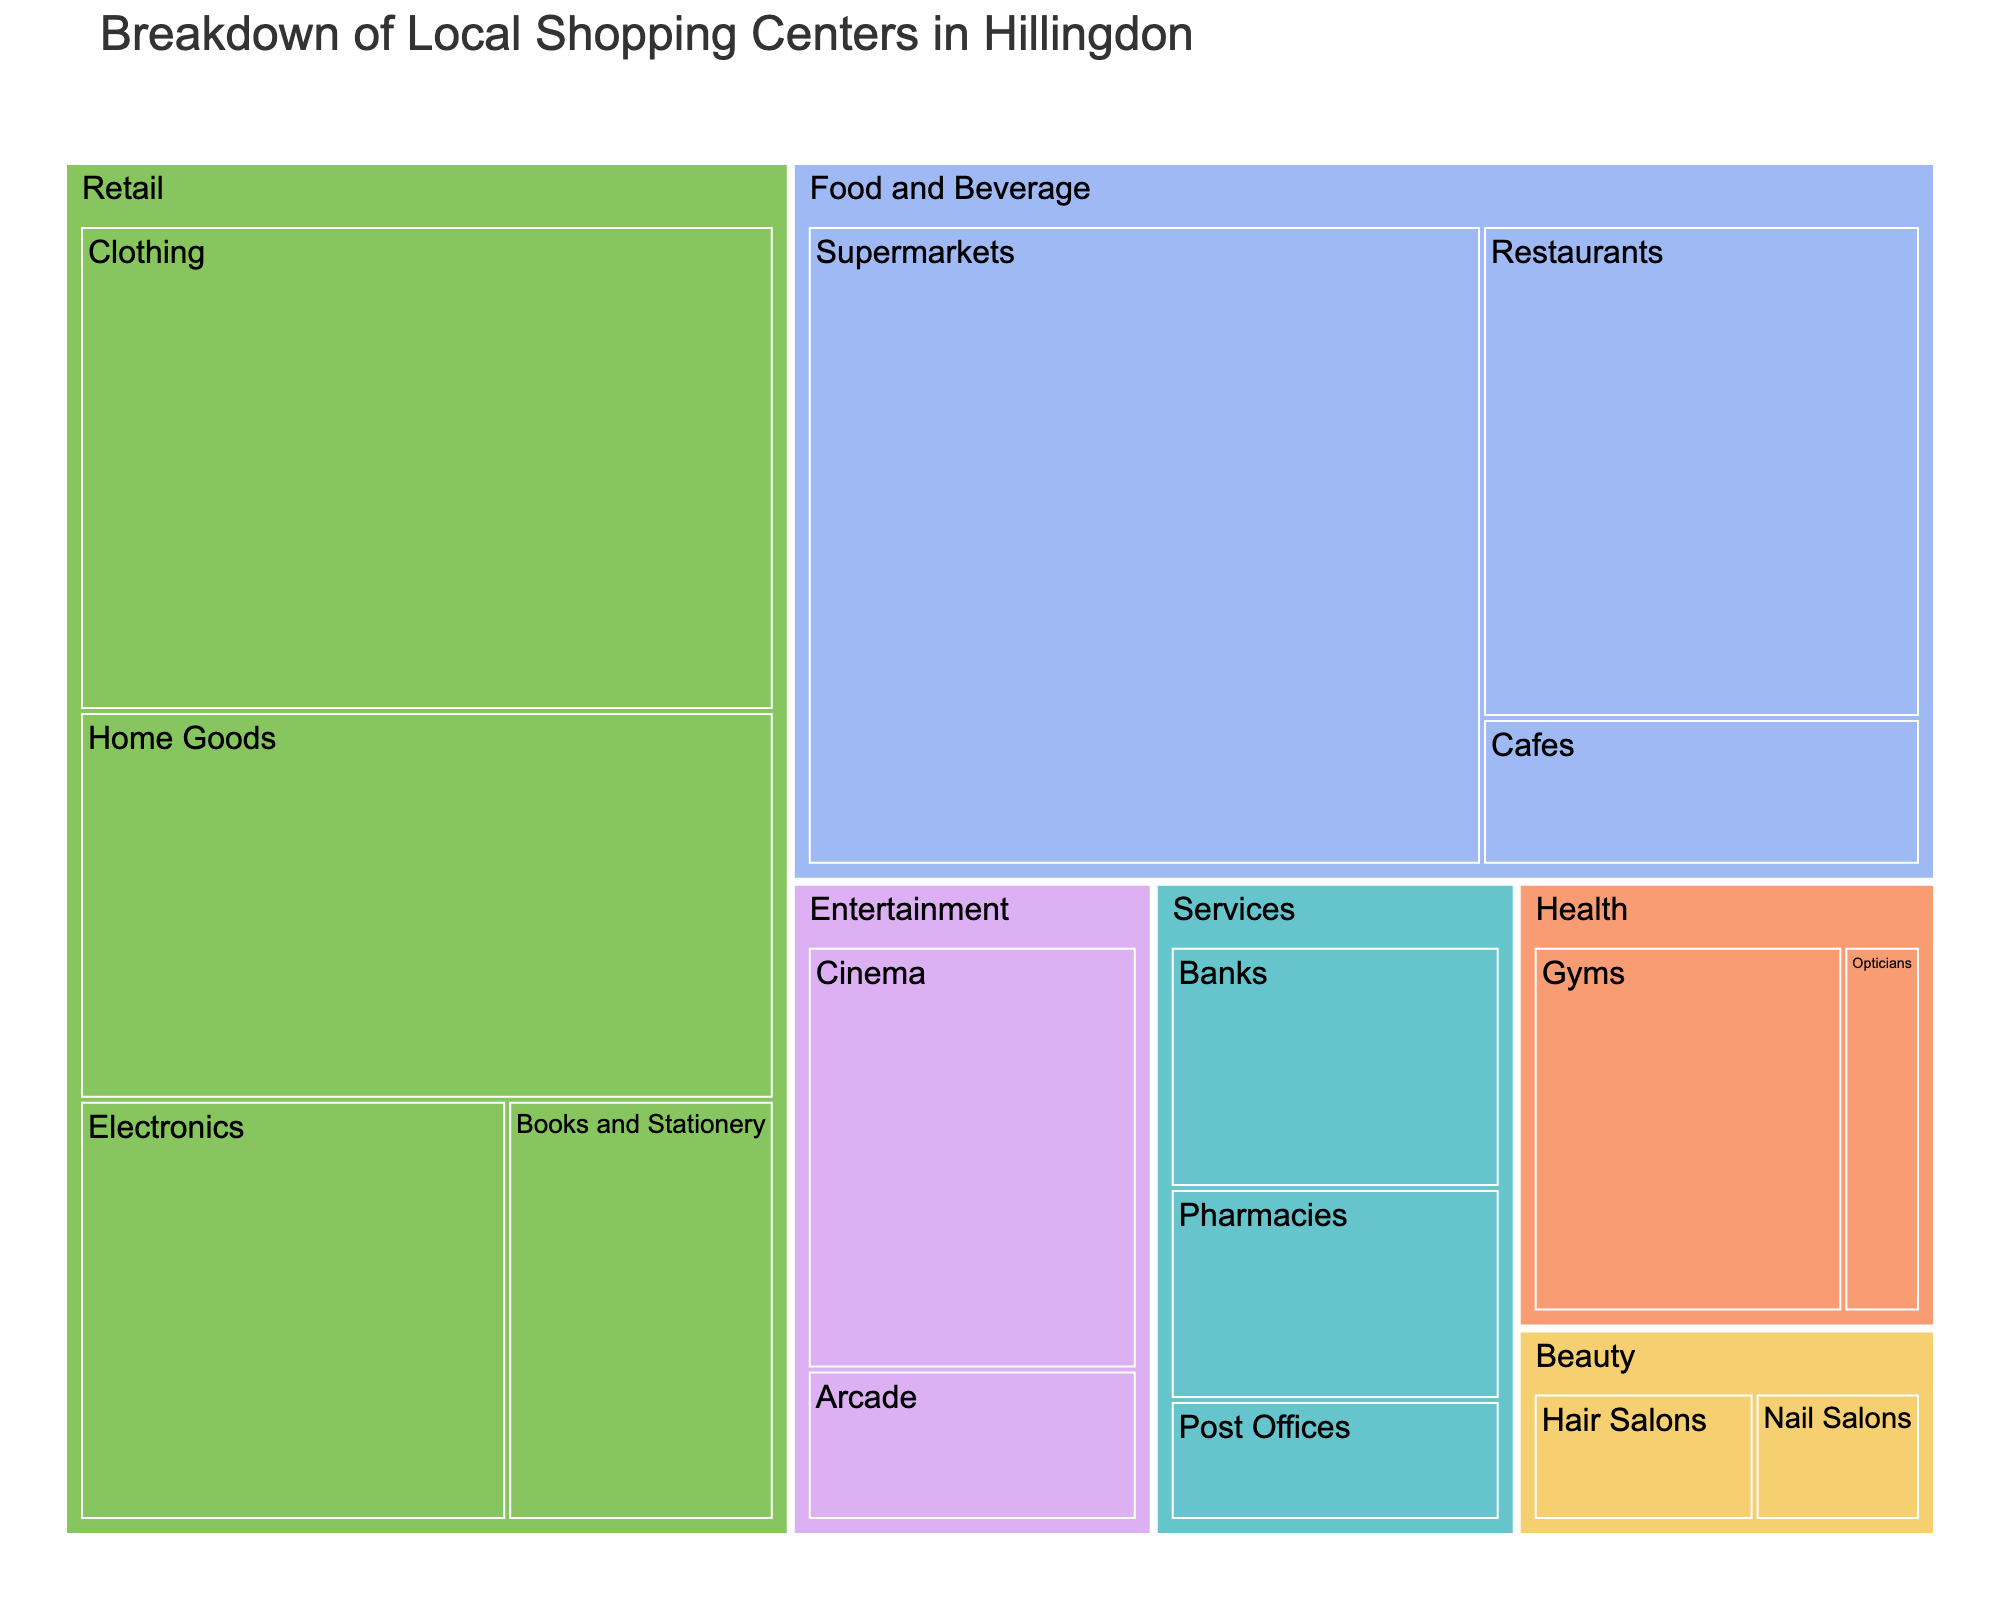How many main store categories are represented in the treemap? The treemap groups stores into main categories. By counting the top-level categories in the treemap, we can find the number of main store categories.
Answer: 6 Which subcategory under Retail has the largest floor space? Examine the size of the subcategory boxes under Retail. The largest box indicates the subcategory with the most floor space.
Answer: Clothing How does the floor space of Gyms compare to that of Hair Salons? Identify the Gyms and Hair Salons boxes in the treemap. Compare their floor space values; Gyms have 6000 sq ft while Hair Salons have 2000 sq ft.
Answer: Gyms have more floor space What is the total floor space allocated to Food and Beverage? Add the floor space of all subcategories under Food and Beverage: Supermarkets (20000), Restaurants (10000), and Cafes (3000). The sum is 33000 sq ft.
Answer: 33000 sq ft Which subcategory under Services has the smallest floor space? Look at the subcategories under Services and identify the one with the smallest box. Post Offices have 2000 sq ft.
Answer: Post Offices What proportion of the total Retail floor space is used by Electronics? First, sum the floor space for all Retail subcategories: Clothing (15000), Electronics (8000), Home Goods (12000), Books and Stationery (5000); total is 40000. Then, calculate the proportion of Electronics using (8000 / 40000) = 0.2 or 20%.
Answer: 20% Which category has more floor space: Entertainment or Beauty? Sum the floor spaces for subcategories under Entertainment (Cinema: 7000, Arcade: 2500) and Beauty (Hair Salons: 2000, Nail Salons: 1500). Entertainment has 9500 sq ft, and Beauty has 3500 sq ft.
Answer: Entertainment If all Services subcategories were combined, what total floor space would they occupy? Sum the floor space for Banks (4000), Pharmacies (3500), and Post Offices (2000). The total is (4000 + 3500 + 2000) = 9500 sq ft.
Answer: 9500 sq ft Out of all Entertainment subcategories, which has the larger floor space? Compare the floor space values for Cinema (7000) and Arcade (2500). Cinema has a larger floor space.
Answer: Cinema Which subcategory occupies less than 2000 sq ft? Inspect each subcategory's floor space in the treemap. The subcategories occupying less than 2000 sq ft are Nail Salons (1500) and Opticians (1500).
Answer: Nail Salons, Opticians 